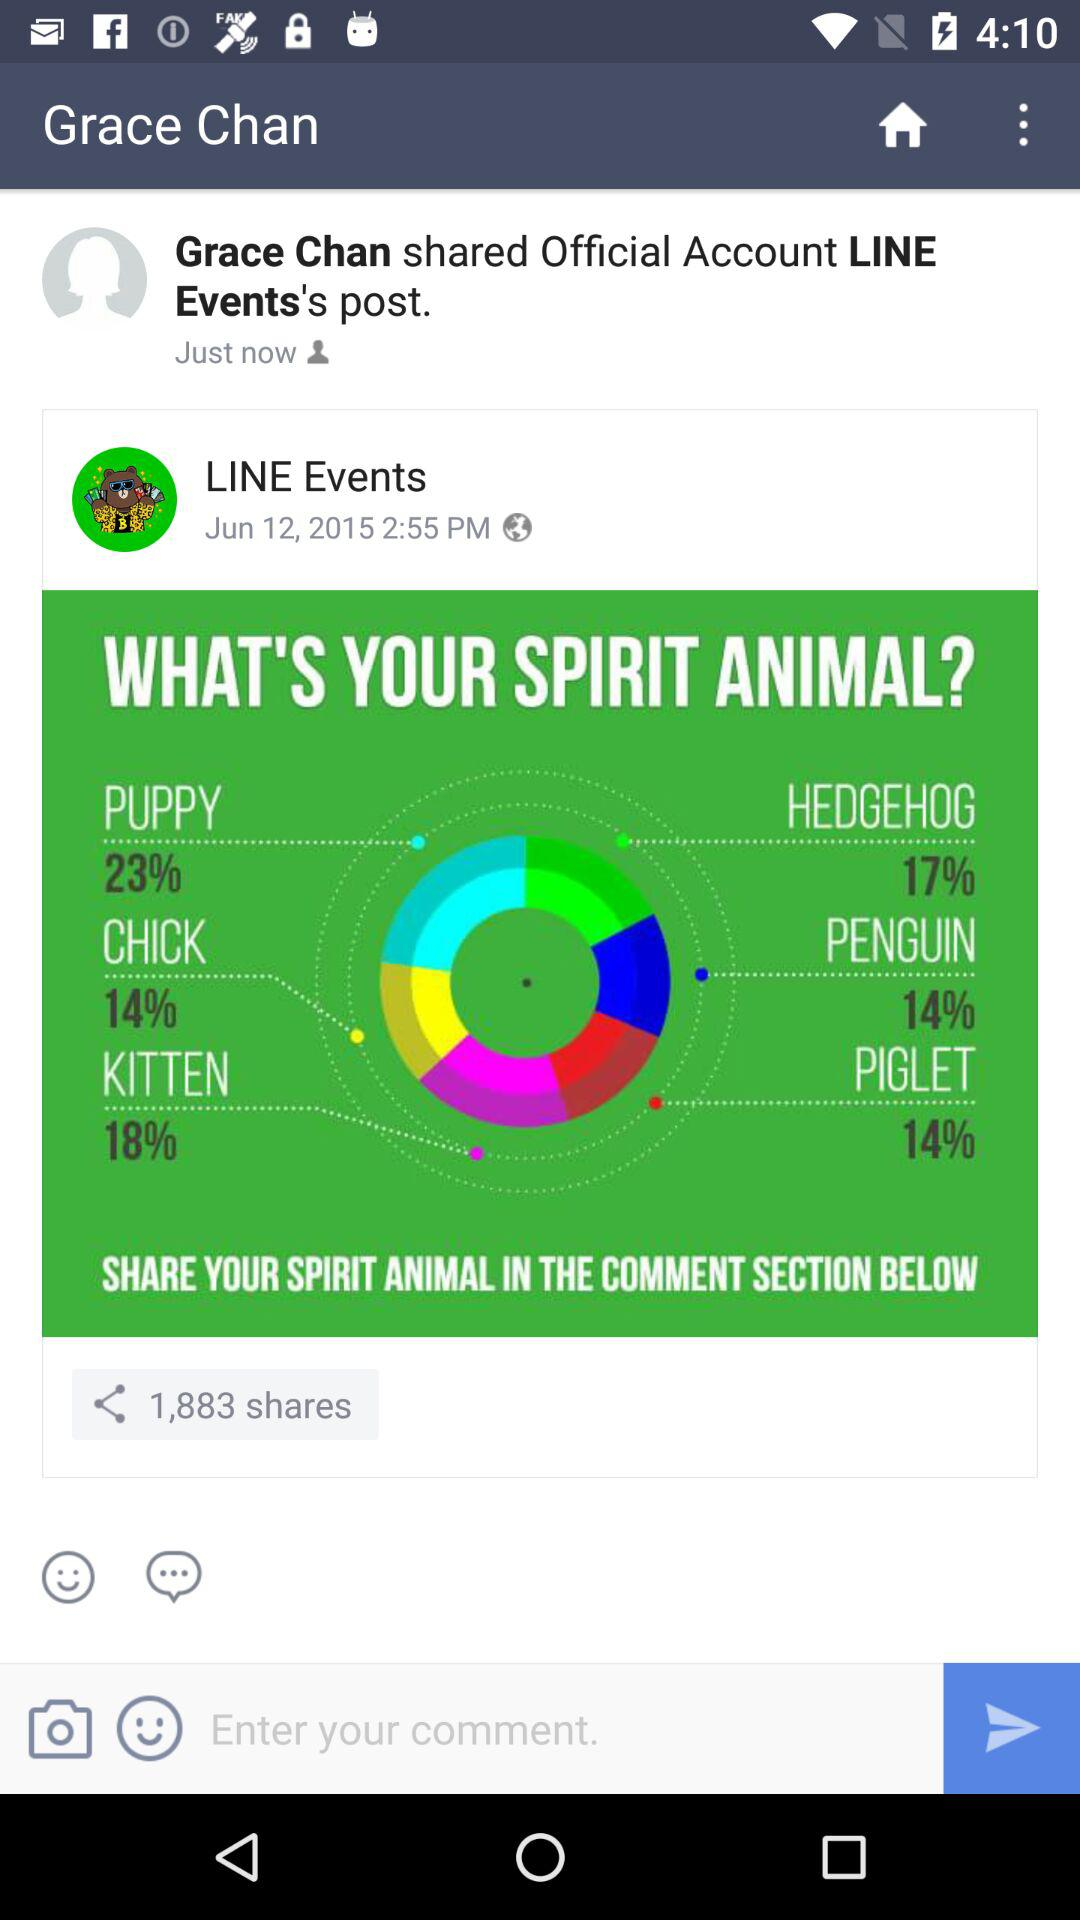What is the percentage of hedgehogs? The percentage of hedgehogs is 17. 